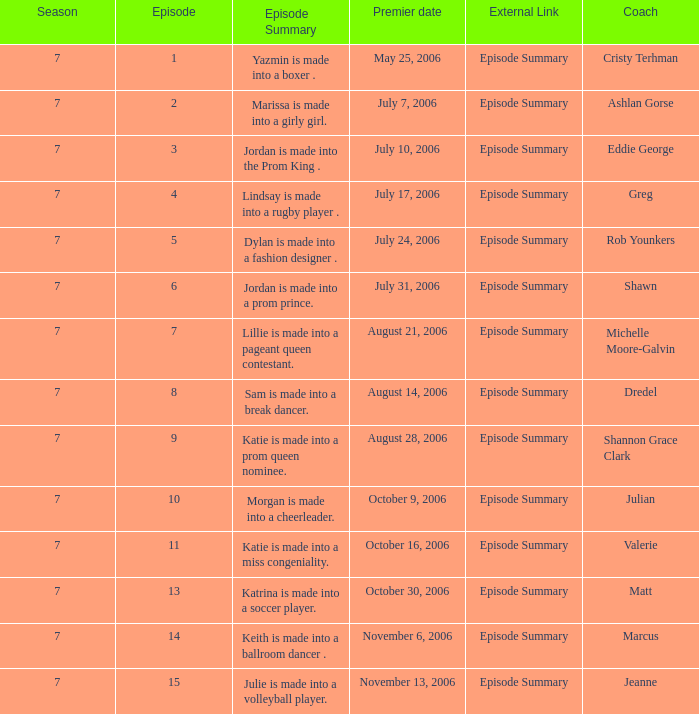How many episodes have a premier date of july 24, 2006 1.0. 